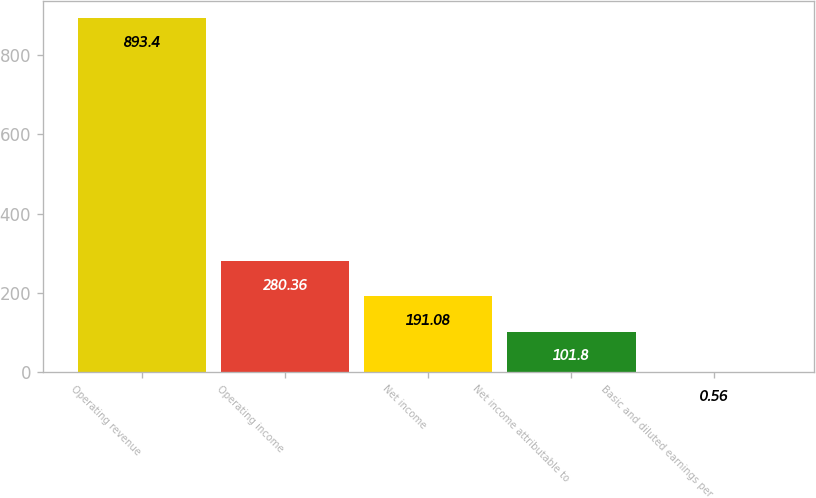<chart> <loc_0><loc_0><loc_500><loc_500><bar_chart><fcel>Operating revenue<fcel>Operating income<fcel>Net income<fcel>Net income attributable to<fcel>Basic and diluted earnings per<nl><fcel>893.4<fcel>280.36<fcel>191.08<fcel>101.8<fcel>0.56<nl></chart> 